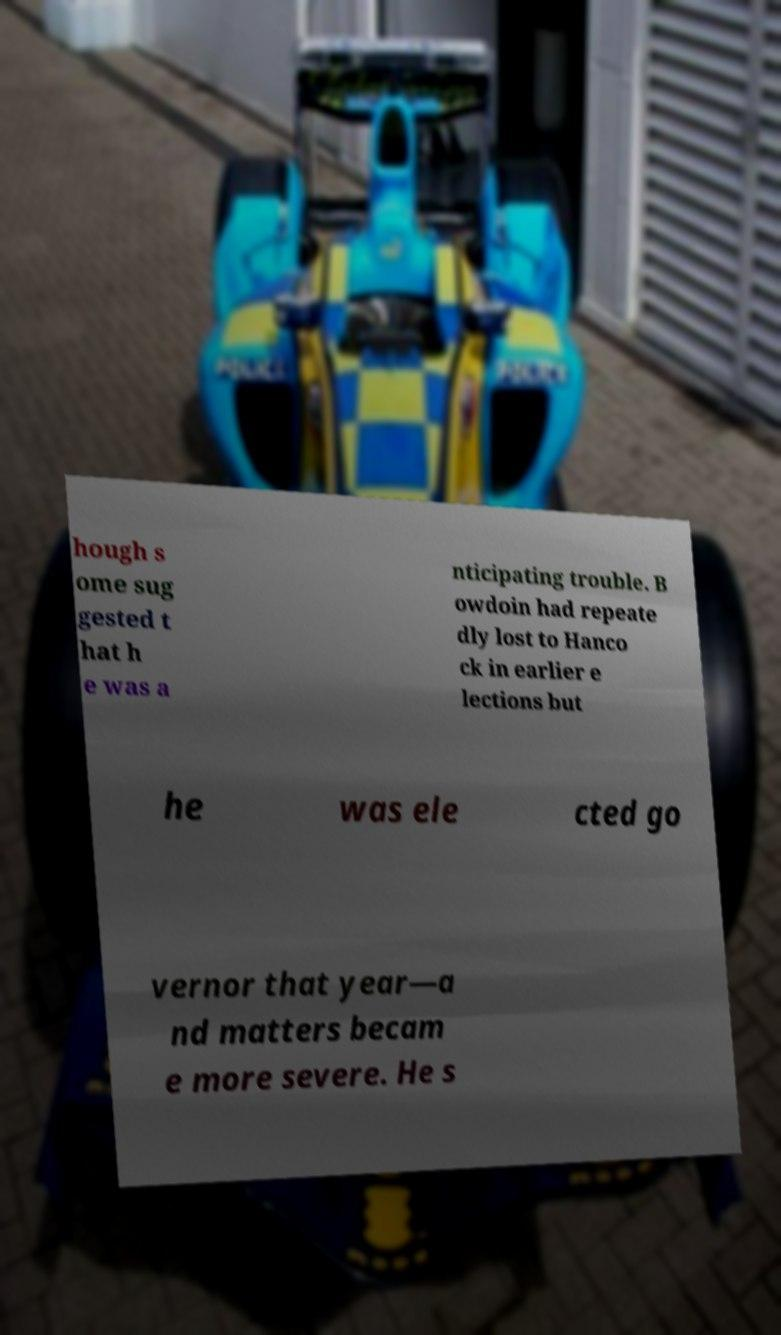I need the written content from this picture converted into text. Can you do that? hough s ome sug gested t hat h e was a nticipating trouble. B owdoin had repeate dly lost to Hanco ck in earlier e lections but he was ele cted go vernor that year—a nd matters becam e more severe. He s 